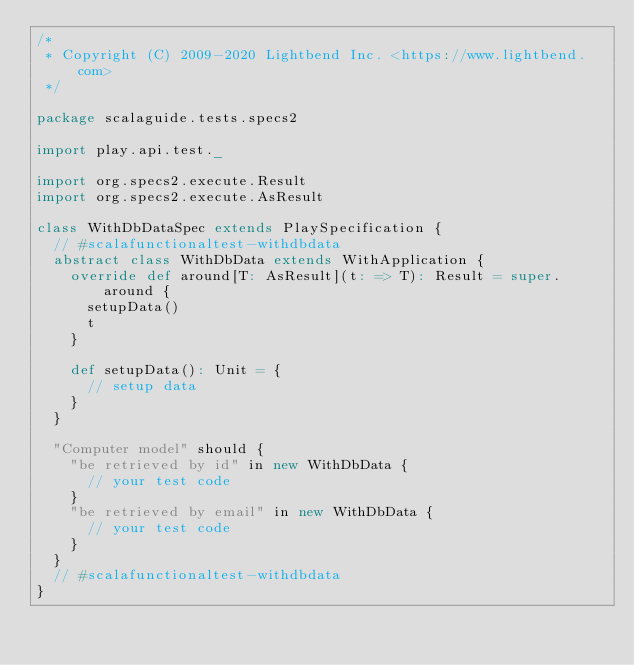<code> <loc_0><loc_0><loc_500><loc_500><_Scala_>/*
 * Copyright (C) 2009-2020 Lightbend Inc. <https://www.lightbend.com>
 */

package scalaguide.tests.specs2

import play.api.test._

import org.specs2.execute.Result
import org.specs2.execute.AsResult

class WithDbDataSpec extends PlaySpecification {
  // #scalafunctionaltest-withdbdata
  abstract class WithDbData extends WithApplication {
    override def around[T: AsResult](t: => T): Result = super.around {
      setupData()
      t
    }

    def setupData(): Unit = {
      // setup data
    }
  }

  "Computer model" should {
    "be retrieved by id" in new WithDbData {
      // your test code
    }
    "be retrieved by email" in new WithDbData {
      // your test code
    }
  }
  // #scalafunctionaltest-withdbdata
}
</code> 